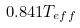<formula> <loc_0><loc_0><loc_500><loc_500>0 . 8 4 1 T _ { e f f }</formula> 